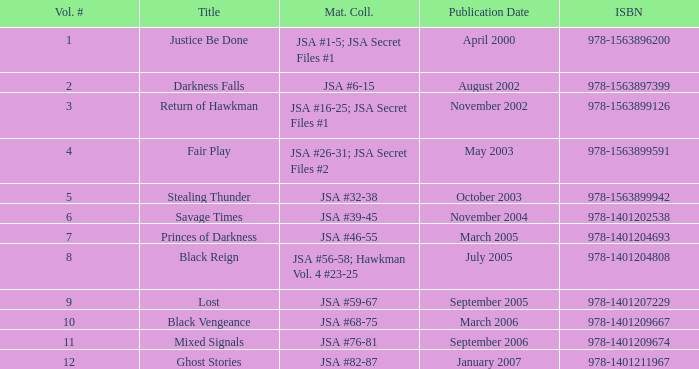How many Volume Numbers have the title of Darkness Falls? 2.0. 